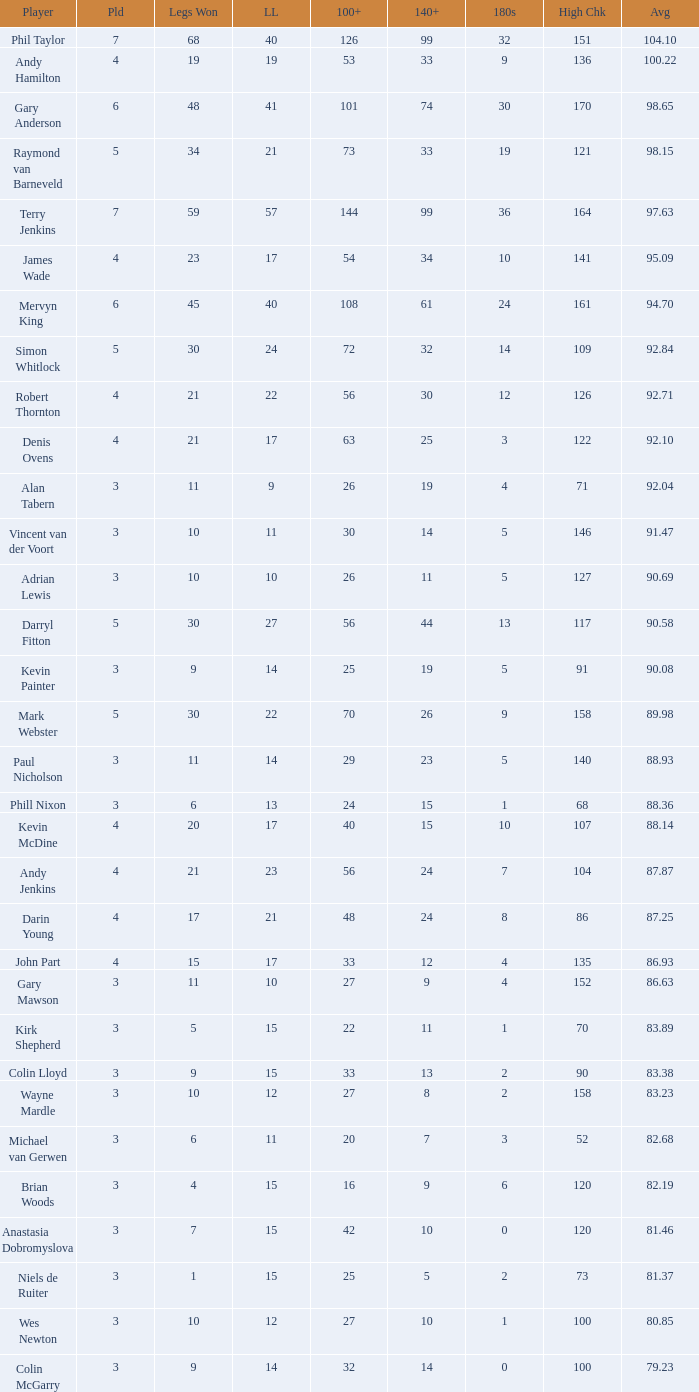What is the high checkout when Legs Won is smaller than 9, a 180s of 1, and a 3-dart Average larger than 88.36? None. 